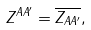<formula> <loc_0><loc_0><loc_500><loc_500>Z ^ { A A ^ { \prime } } = \overline { Z _ { A A ^ { \prime } } } ,</formula> 